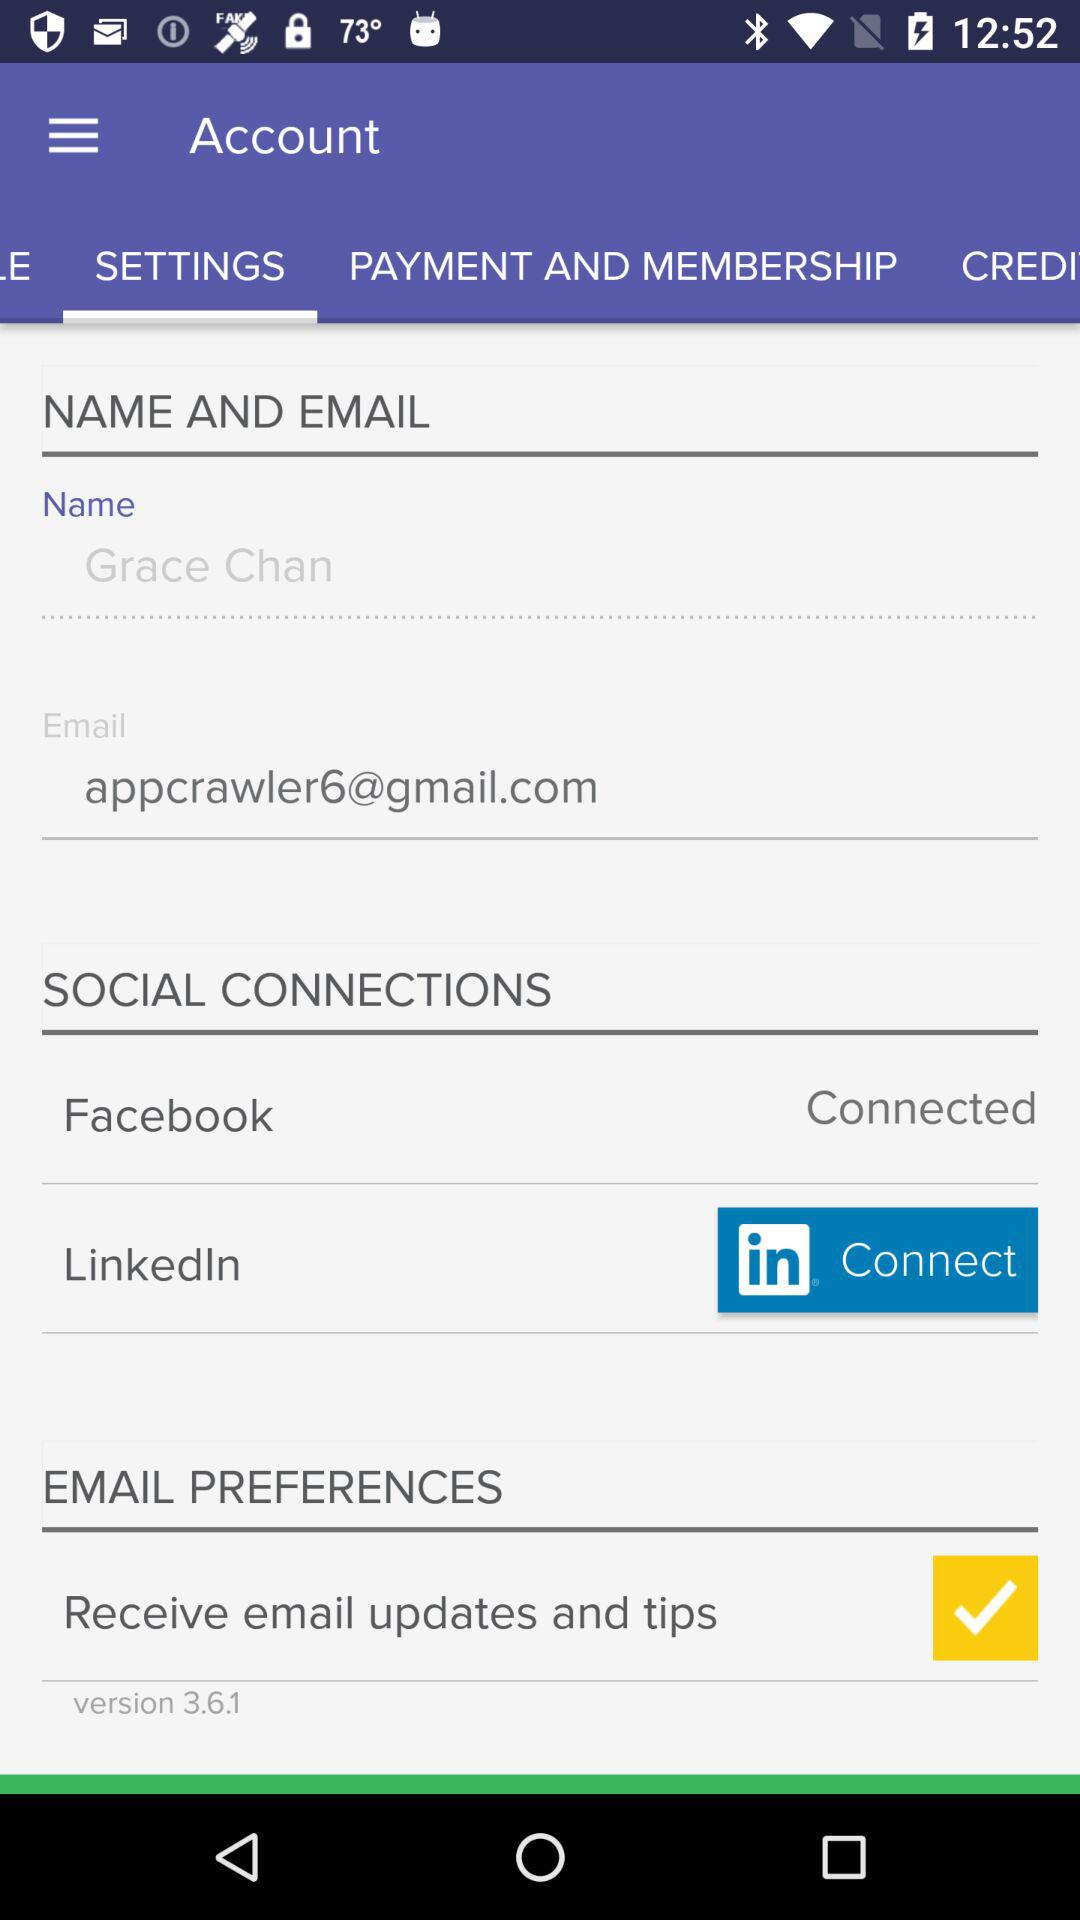How many social connections does the user have?
Answer the question using a single word or phrase. 2 